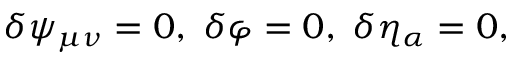<formula> <loc_0><loc_0><loc_500><loc_500>\delta \psi _ { \mu \nu } = 0 , \, \delta \varphi = 0 , \, \delta \eta _ { \alpha } = 0 ,</formula> 